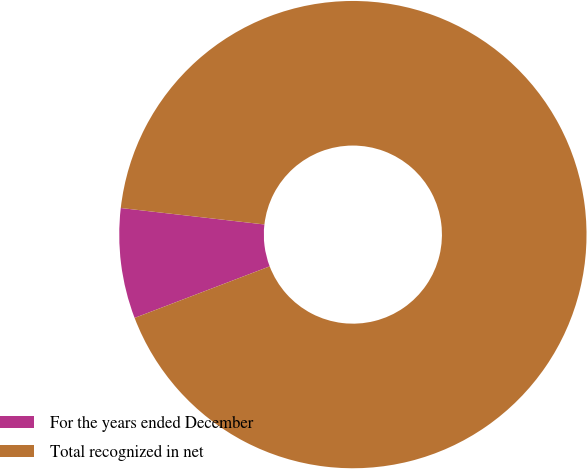Convert chart to OTSL. <chart><loc_0><loc_0><loc_500><loc_500><pie_chart><fcel>For the years ended December<fcel>Total recognized in net<nl><fcel>7.62%<fcel>92.38%<nl></chart> 